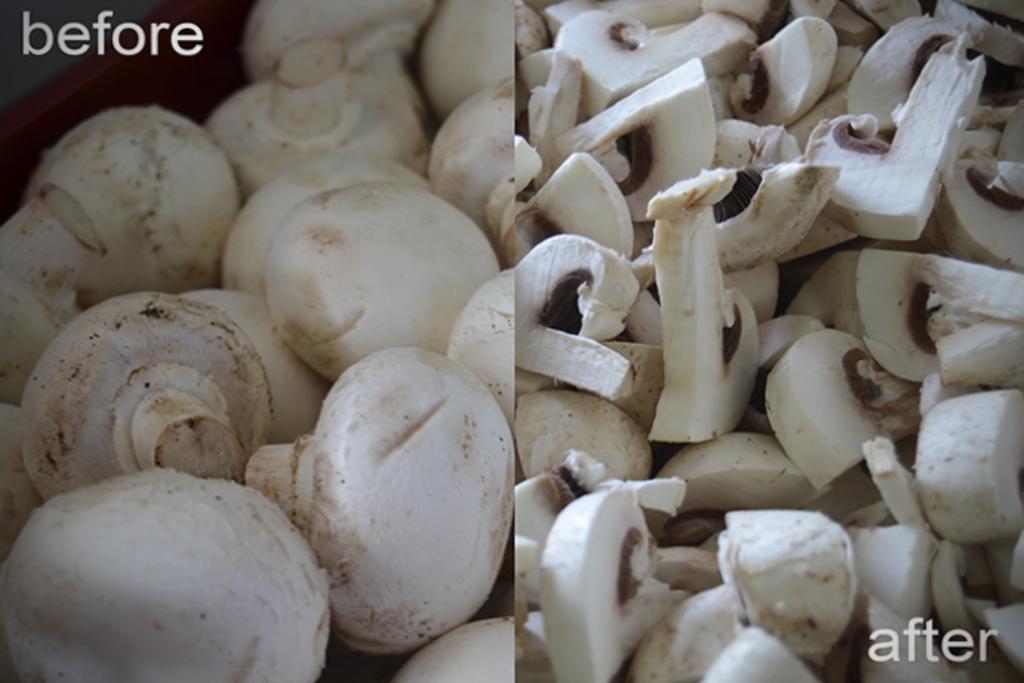Please provide a concise description of this image. This is a collage image. On the left side of the image we can see the mushrooms. On the right side of the image we can see the mushroom slices. In the bottom right corner we can see the text. In the top left corner we can see the text. 